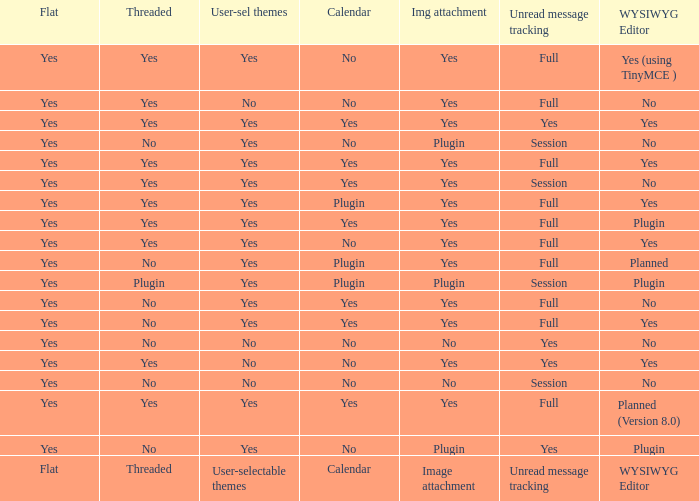Which Calendar has a WYSIWYG Editor of no, and an Unread message tracking of session, and an Image attachment of no? No. 